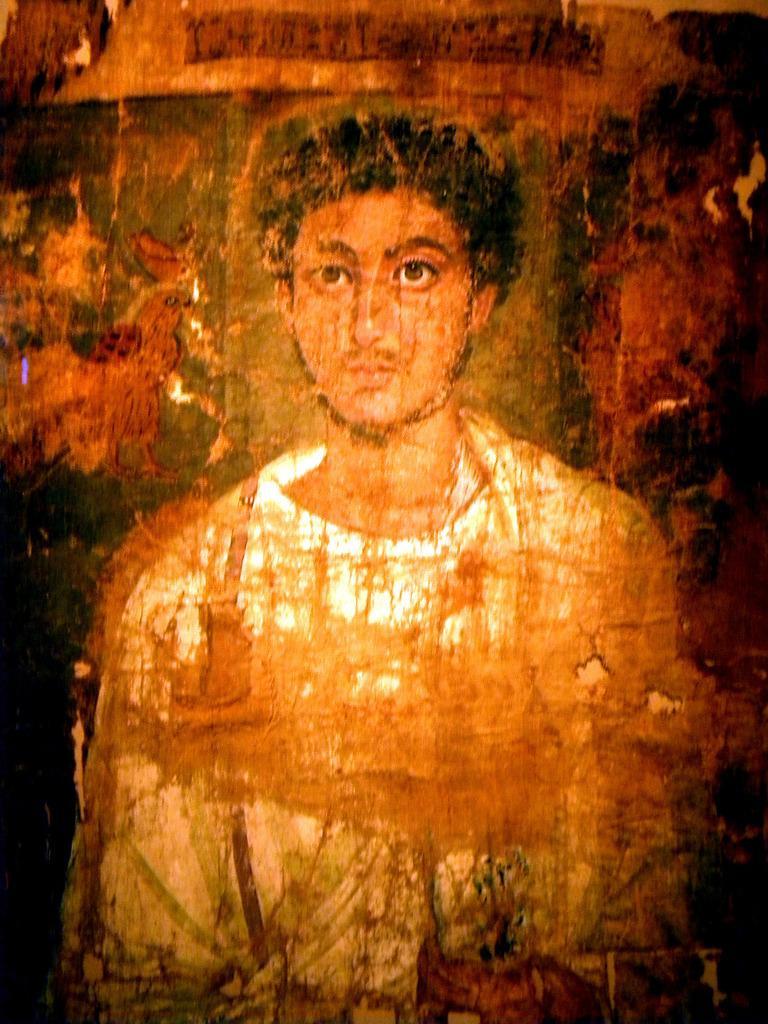Could you give a brief overview of what you see in this image? In this picture we can see a painting of a person. 